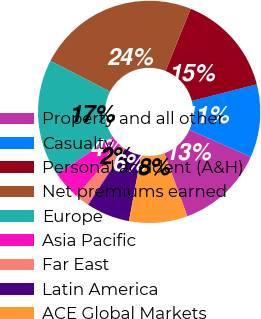Convert chart to OTSL. <chart><loc_0><loc_0><loc_500><loc_500><pie_chart><fcel>Property and all other<fcel>Casualty<fcel>Personal accident (A&H)<fcel>Net premiums earned<fcel>Europe<fcel>Asia Pacific<fcel>Far East<fcel>Latin America<fcel>ACE Global Markets<nl><fcel>12.78%<fcel>10.63%<fcel>14.92%<fcel>23.5%<fcel>17.07%<fcel>4.2%<fcel>2.06%<fcel>6.35%<fcel>8.49%<nl></chart> 